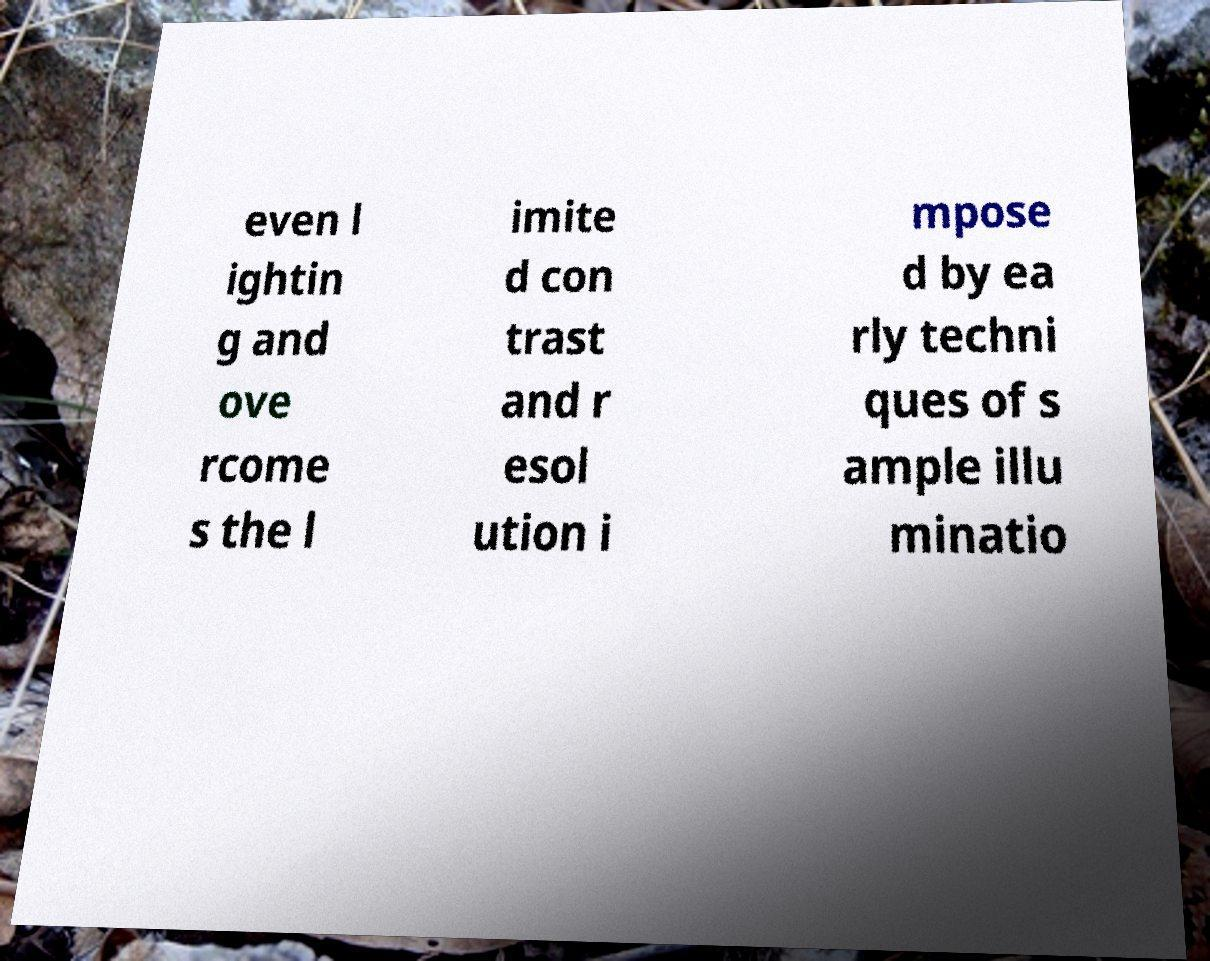Can you read and provide the text displayed in the image?This photo seems to have some interesting text. Can you extract and type it out for me? even l ightin g and ove rcome s the l imite d con trast and r esol ution i mpose d by ea rly techni ques of s ample illu minatio 